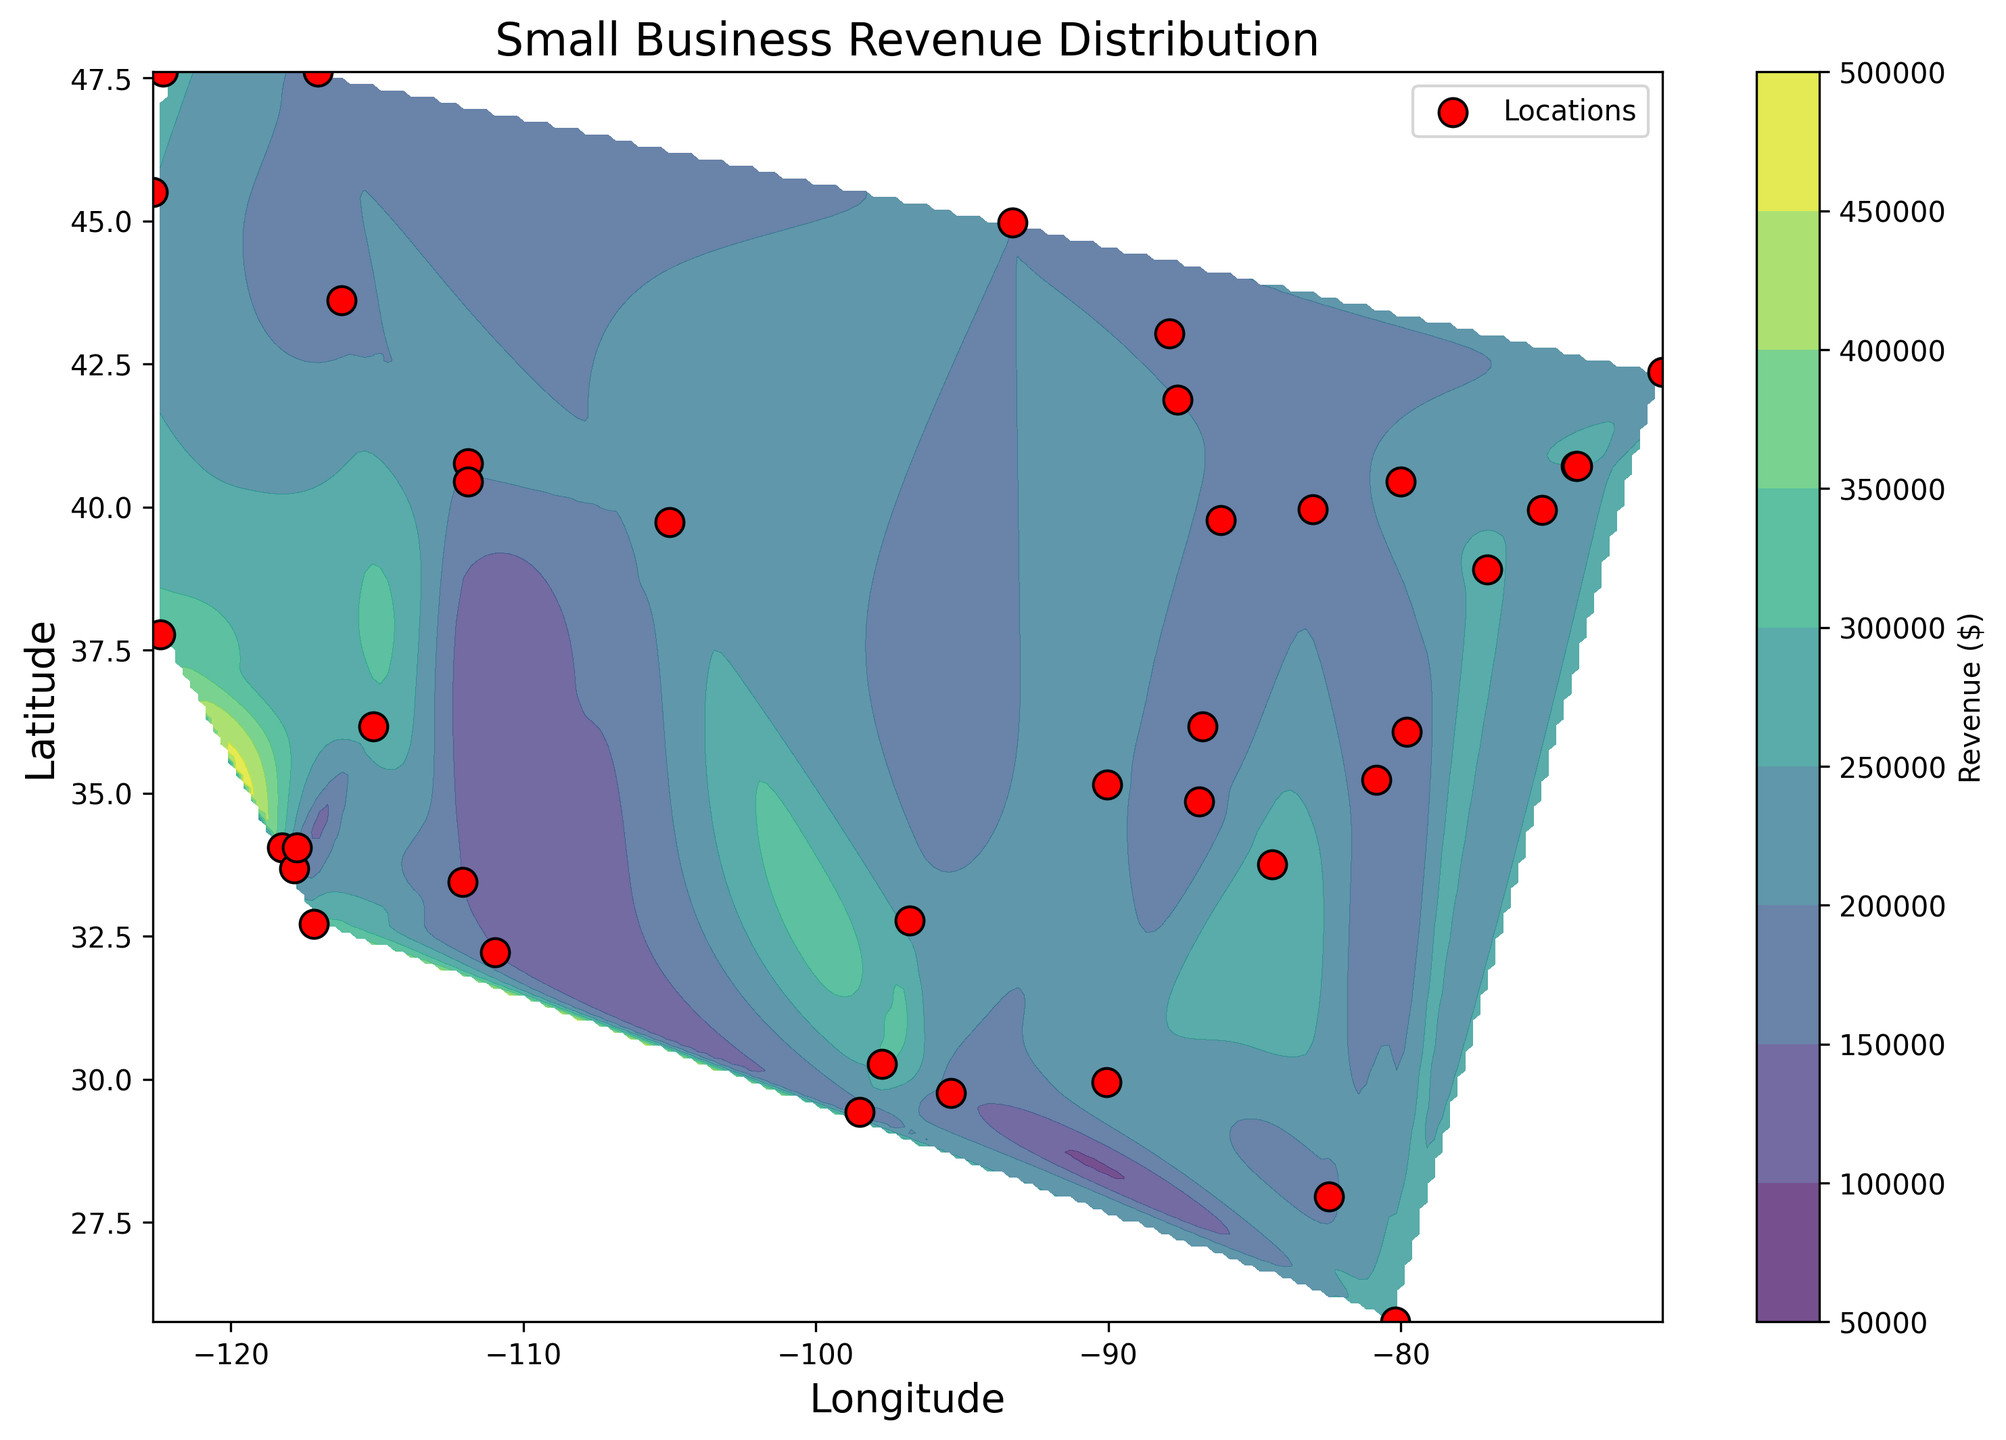What is the range of small business revenues depicted in the plot? The plot shows varying levels of revenue across different locations, indicated by the color gradient in the contour plot. To find the range, identify the minimum and maximum values in the color bar legend. This will give the range.
Answer: $150,000 to $320,000 Which area has the highest small business revenue according to the color gradient in the contour plot? The color gradient in the contour plot ranges from dark purple (lowest revenue) to yellow (highest revenue). By identifying the regions with the yellow color, which signifies higher revenues, we can determine the areas with the highest revenue.
Answer: San Francisco, CA (latitude 37.7749, longitude -122.4194) Compare the revenue between businesses located in the Southeast versus those in the Northwest, which region typically shows higher revenues? The regions in the Southeast (e.g., locations near Atlanta, GA) and Northwest (e.g., Seattle, WA) can be compared by examining the contour colors. Southeast areas are more towards purple and blue, while Northwest areas are more towards green and yellow. Green and yellow indicate higher revenue.
Answer: Northwest What is the average revenue of small businesses located within the coordinates that cover California? To find this, identify all points within California. The coordinates include Los Angeles (34.0522, -118.2437), San Francisco (37.7749, -122.4194), Irvine (33.6846, -117.8265). Calculate their average revenue by summing their revenues and dividing by the number of points. Los Angeles ($310,000), San Francisco ($320,000), Irvine ($205,000).
Answer: ($310,000 + $320,000 + $205,000) / 3 = $278,333 How does the small business revenue in New York (Lat: 40.7128, Long: -74.0060) compare to that in Los Angeles (Lat: 34.0522, Long: -118.2437)? By finding the specific scatter points for New York and Los Angeles and comparing the associated revenues, we see New York is marked at $250,000, while Los Angeles is marked at $310,000.
Answer: Los Angeles is higher What is the dominant color in the contour plot, and what does it indicate about the overall revenue distribution? Identify the most prevalent color in the contour plot and refer to the color legend. The dominant color indicates the general revenue level. For instance, if dark green is dominant, it suggests a mid-range revenue.
Answer: Dark green, indicating mid-range revenues around $200,000 - $250,000 What evidence does the plot provide to indicate areas with relatively lower small business revenues? Areas with darker shades of purple in the contour plot are visual indicators of lower revenues. These areas can be cross-referenced with specific points for exact locations where the plot shows scatter points in the darker regions.
Answer: Regions like Phoenix, AZ (Lat: 33.4484, Long: -112.0740) Which city shows a revenue of approximately $180,000 and where is it located on the contour plot? Identify the scatter points that align with $180,000 revenue. Cross-reference the coordinates with the data to find the city.
Answer: Houston, TX (Lat: 29.7604, Long: -95.3698) Is there a correlation between latitude and revenue, based on the contour plot's visual gradient? Analyze the trend shown by the color gradients in the contour plot. If higher revenues correlate with certain latitude bands, such as lower latitudes showing higher revenues, this could indicate a correlation.
Answer: No strong visual correlation Which city shows a significant deviation in revenue compared to its neighbors in the contour plot? Identify cities that are marked with scatter points significantly diverging in color (revenue level) compared to nearby points in the same geographic area.
Answer: San Francisco, CA (Lat: 37.7749, Long: -122.4194) which shows very high revenue compared to nearby locations 